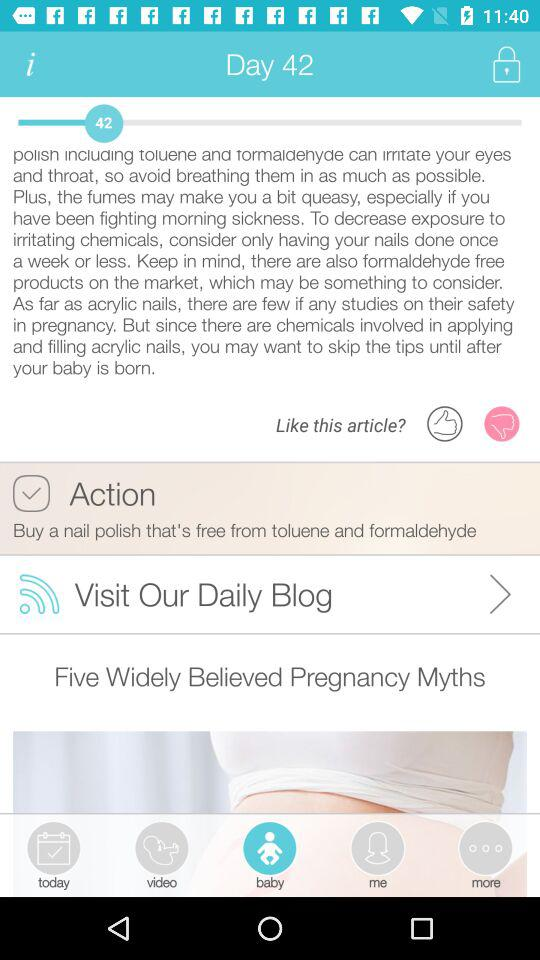Which tab is selected? The selected tab is "Baby". 